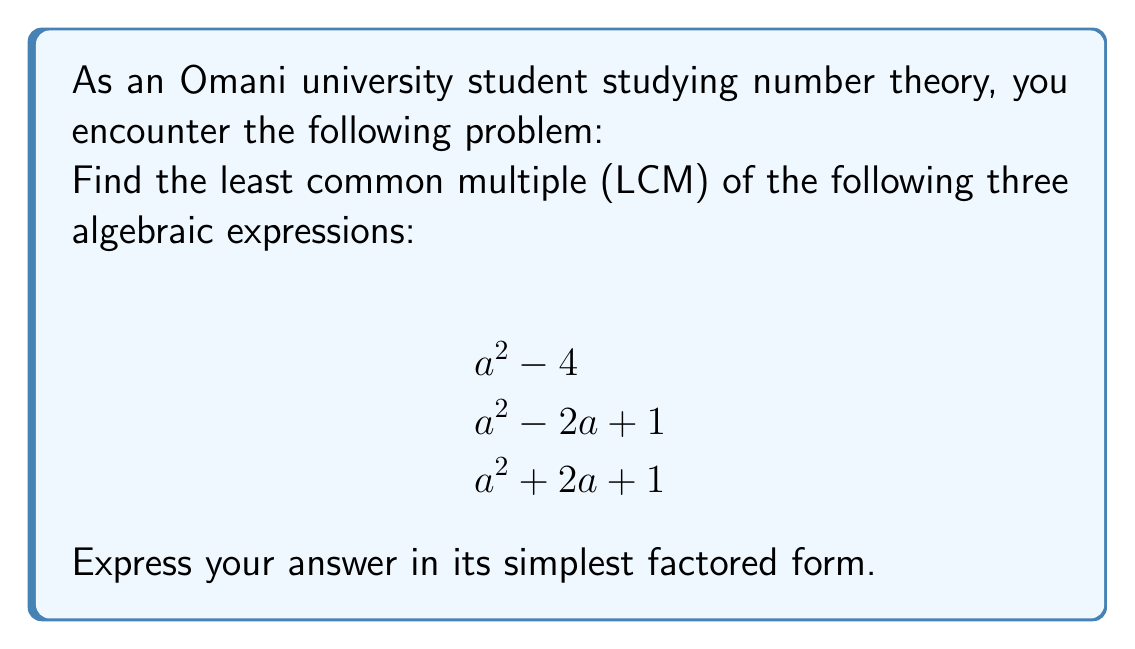What is the answer to this math problem? To find the LCM of these algebraic expressions, we'll follow these steps:

1) First, let's factor each expression:

   $a^2 - 4 = (a+2)(a-2)$
   $a^2 - 2a + 1 = (a-1)^2$
   $a^2 + 2a + 1 = (a+1)^2$

2) The LCM will include all unique factors with their highest powers. Let's identify these:

   $(a+2)$ appears once
   $(a-2)$ appears once
   $(a-1)$ appears with a power of 2
   $(a+1)$ appears with a power of 2

3) Therefore, the LCM will be the product of these factors:

   $LCM = (a+2)(a-2)(a-1)^2(a+1)^2$

4) This is already in its simplest factored form, as none of these factors can be combined or simplified further.
Answer: $$(a+2)(a-2)(a-1)^2(a+1)^2$$ 